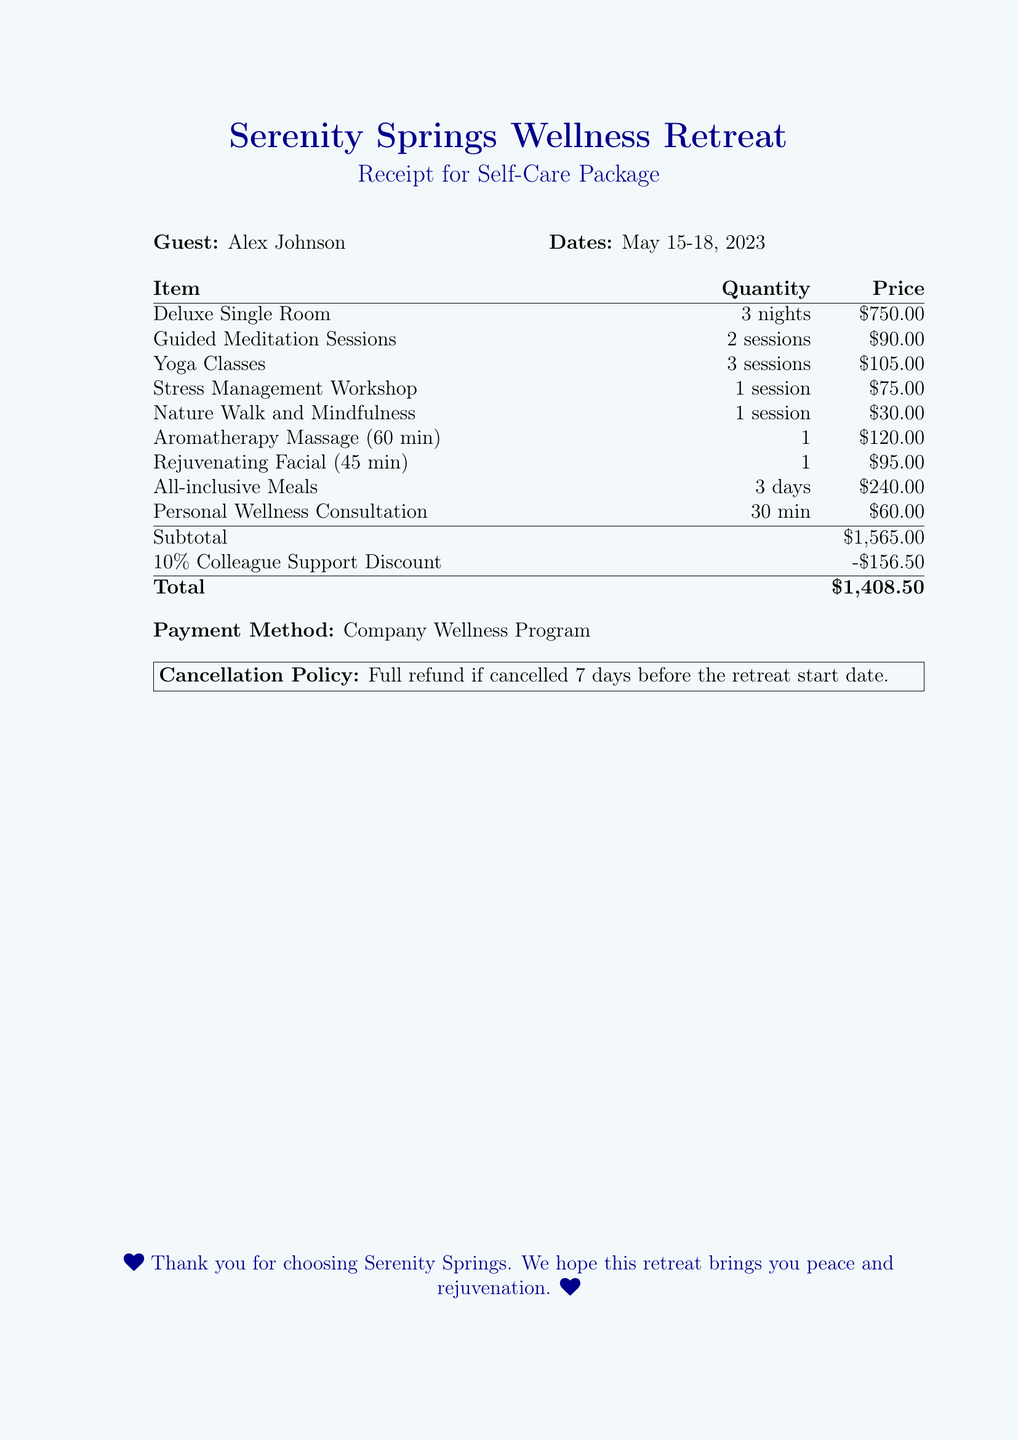what is the guest's name? The guest's name is listed at the top of the receipt.
Answer: Alex Johnson what dates did the retreat occur? The dates of the retreat are specified in the document.
Answer: May 15-18, 2023 how many nights did the guest stay? The number of nights is noted in the accommodations section of the document.
Answer: 3 nights what is the total amount charged? The total amount is shown at the bottom of the billing table.
Answer: $1,408.50 what discount was applied to the total? The discount mentioned in the document is shown in the billing table.
Answer: -$156.50 how many guided meditation sessions were included? The quantity of guided meditation sessions is listed in the wellness activities section.
Answer: 2 sessions what is the price of the rejuvenating facial? The price for the rejuvenating facial is found in the price column of the bill.
Answer: $95.00 what is the payment method for the retreat? The payment method is specified in a section of the document.
Answer: Company Wellness Program what is the cancellation policy? The cancellation policy is stated in a boxed section of the document.
Answer: Full refund if cancelled 7 days before the retreat start date 